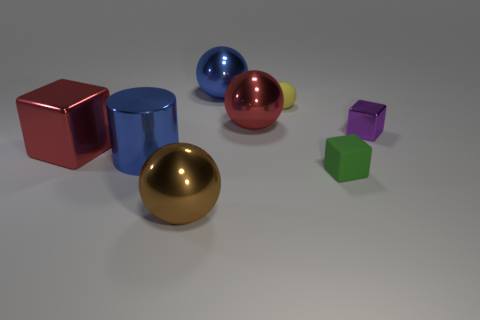There is a metal thing that is on the left side of the blue shiny cylinder; what color is it?
Your answer should be very brief. Red. Are there any green cubes that have the same size as the purple shiny block?
Your answer should be compact. Yes. There is a blue cylinder that is the same size as the brown ball; what is its material?
Your answer should be very brief. Metal. Do the brown object and the metallic ball behind the tiny yellow rubber ball have the same size?
Offer a terse response. Yes. There is a small cube that is in front of the purple metal object; what is its material?
Your answer should be compact. Rubber. Are there the same number of purple things behind the small purple object and big yellow rubber cubes?
Provide a short and direct response. Yes. Does the red metallic ball have the same size as the blue sphere?
Your answer should be compact. Yes. There is a sphere that is in front of the small cube to the right of the green matte cube; is there a rubber cube that is behind it?
Provide a short and direct response. Yes. There is a big red object that is the same shape as the tiny yellow matte thing; what is its material?
Keep it short and to the point. Metal. There is a tiny rubber thing behind the large cube; how many big blue metal spheres are in front of it?
Your response must be concise. 0. 